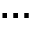<formula> <loc_0><loc_0><loc_500><loc_500>\dots</formula> 